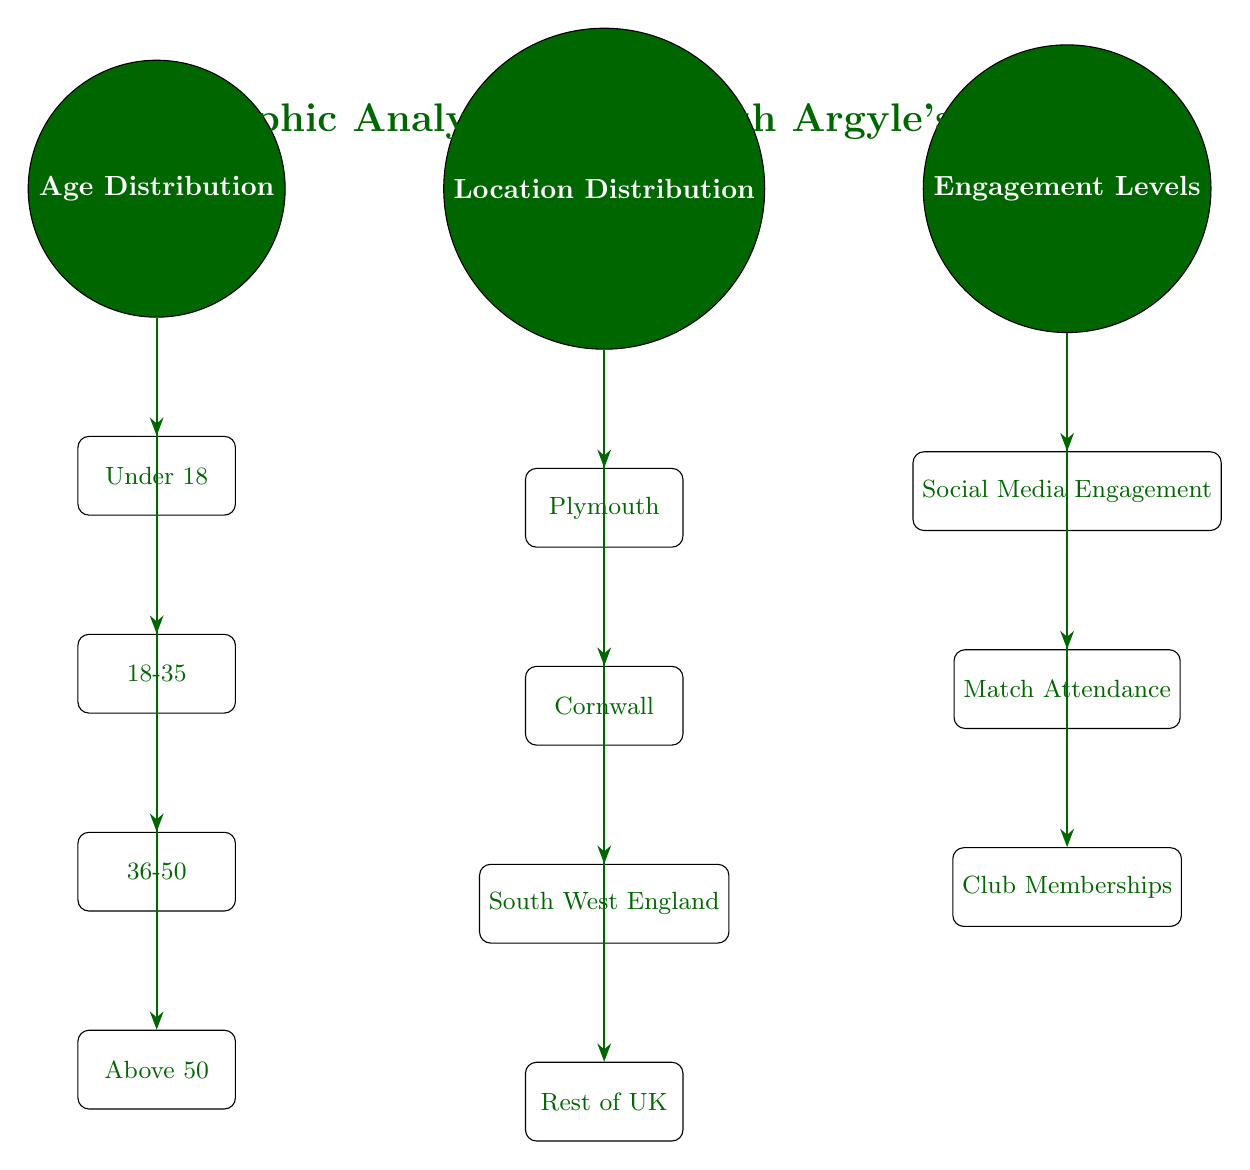What categories are represented under Age Distribution? The Age Distribution node connects to four sub-nodes: Under 18, 18-35, 36-50, and Above 50, indicating the range of age categories represented.
Answer: Under 18, 18-35, 36-50, Above 50 How many total categories are shown in Location Distribution? The Location Distribution node has four sub-nodes: Plymouth, Cornwall, South West England, and Rest of UK, providing a total count of location categories.
Answer: 4 Which engagement type is listed first under Engagement Levels? The Engagement Levels node directs downward to three sub-nodes, with Social Media Engagement as the first one listed, indicating its priority.
Answer: Social Media Engagement Are there more nodes under Age Distribution or Location Distribution? Age Distribution has four sub-nodes while Location Distribution also has four sub-nodes; there is an equal number in both categories.
Answer: Equal What is the relationship between Engagement Levels and Age Distribution in this diagram? The diagram shows that Engagement Levels and Age Distribution are separate main categories with their respective sub-nodes, but no direct arrows link them, indicating they are distinct analyses.
Answer: No direct relationship How many types of engagement are analyzed according to the diagram? Under the Engagement Levels node, there are three engagement types: Social Media Engagement, Match Attendance, and Club Memberships, showing the breadth of engagement analyzed.
Answer: 3 What is the focus of the analysis in the title of the diagram? The title of the diagram indicates the analysis focus is on the demographic profile of Plymouth Argyle's fan base, showcasing the specifics of who the fans are.
Answer: Plymouth Argyle's fan base Which category includes Plymouth as a sub-node? The sub-node Plymouth is included under the Location Distribution node, indicating it is a specific region analyzed within the fan base demographics.
Answer: Location Distribution What color represents the main nodes in the diagram? All main nodes are filled with the color designated as Plymouth green, establishing a cohesive visual theme reflecting the club's identity.
Answer: Plymouth green 